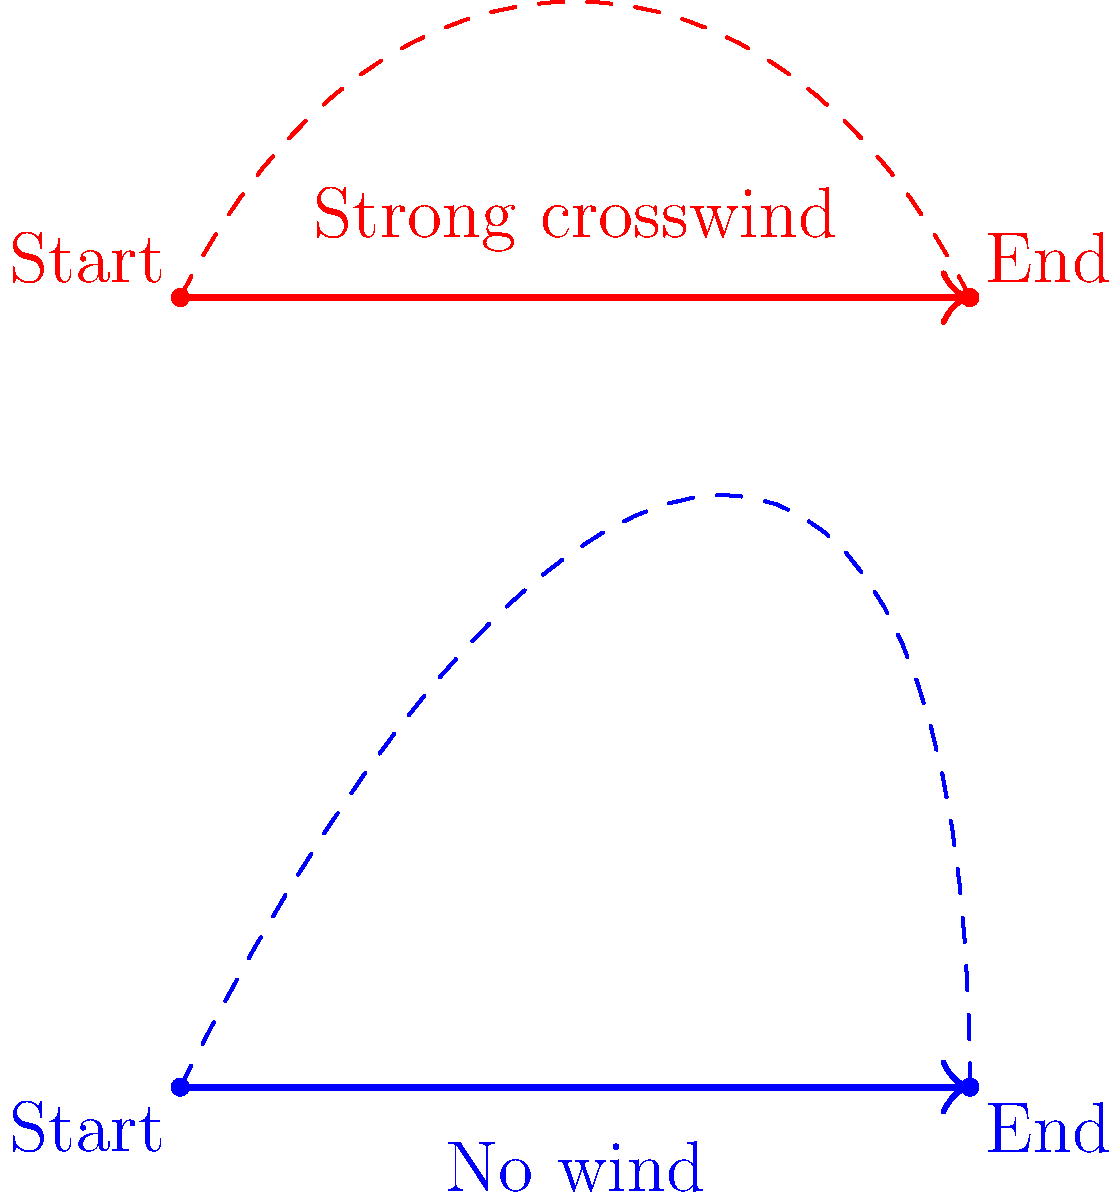As an aspiring documentary maker, you're filming a segment on the physics of boomerangs in the Australian outback. You observe two identical boomerangs thrown with the same initial velocity and angle, but under different wind conditions. The blue trajectory represents a throw with no wind, while the red trajectory shows a throw with a strong crosswind. How does the crosswind affect the boomerang's flight time compared to the no-wind condition? To understand the effect of crosswind on a boomerang's flight time, let's analyze the trajectories step-by-step:

1. No wind condition (blue trajectory):
   - The boomerang follows a symmetrical path.
   - It reaches its maximum height at the midpoint of its trajectory.
   - The flight time is determined by the initial velocity and throwing angle.

2. Strong crosswind condition (red trajectory):
   - The crosswind pushes the boomerang sideways throughout its flight.
   - This results in an asymmetrical path with a higher maximum height.
   - The boomerang travels a longer distance through the air.

3. Effect on flight time:
   - The longer path in the crosswind condition means the boomerang travels a greater distance.
   - According to the equation $t = \frac{d}{v}$, where $t$ is time, $d$ is distance, and $v$ is velocity, a longer distance results in a longer time if the velocity remains constant.
   - The increased maximum height also contributes to a longer time in the air due to the additional vertical distance traveled.

4. Factors affecting velocity:
   - The crosswind may slightly reduce the boomerang's forward velocity.
   - However, the gyroscopic effect of the spinning boomerang helps maintain its stability and overall speed.

5. Overall impact:
   - The increased path length and higher maximum height in the crosswind condition outweigh any minor reduction in velocity.
   - This results in a longer flight time for the boomerang thrown in the crosswind compared to the no-wind condition.
Answer: The crosswind increases the boomerang's flight time. 